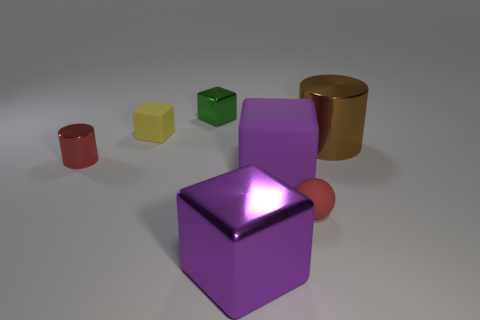There is another block that is the same size as the green shiny cube; what is its color?
Offer a terse response. Yellow. Is there a small sphere that has the same color as the small cylinder?
Your answer should be compact. Yes. Does the small object in front of the small red metal object have the same color as the small metal cylinder?
Provide a short and direct response. Yes. What is the shape of the brown object that is made of the same material as the tiny green object?
Make the answer very short. Cylinder. What is the size of the matte ball?
Ensure brevity in your answer.  Small. How many things are large brown cylinders or large red metallic cylinders?
Give a very brief answer. 1. Does the cylinder that is behind the tiny cylinder have the same material as the cylinder left of the yellow object?
Your response must be concise. Yes. What is the color of the other big thing that is the same material as the big brown thing?
Offer a very short reply. Purple. What number of green cubes are the same size as the brown metal object?
Offer a terse response. 0. What number of other objects are there of the same color as the tiny metal cube?
Your answer should be very brief. 0. 